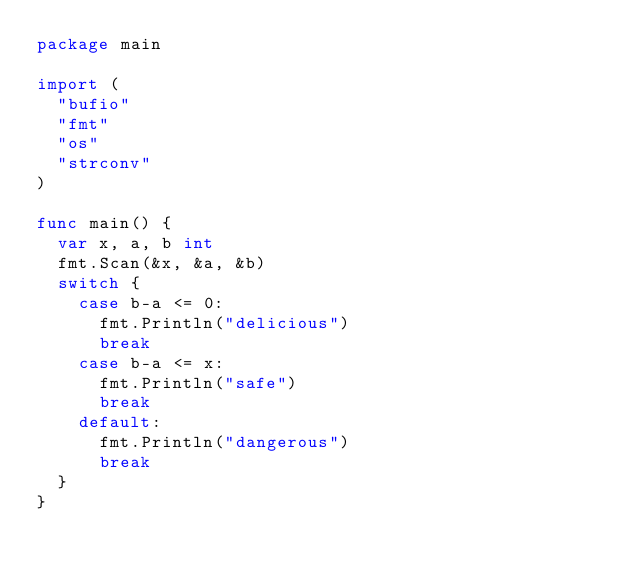Convert code to text. <code><loc_0><loc_0><loc_500><loc_500><_Go_>package main

import (
	"bufio"
	"fmt"
	"os"
	"strconv"
)

func main() {
	var x, a, b int
	fmt.Scan(&x, &a, &b)
	switch {
		case b-a <= 0:
			fmt.Println("delicious")
			break
		case b-a <= x:
			fmt.Println("safe")
			break
		default:
			fmt.Println("dangerous")
			break
	}
}
</code> 